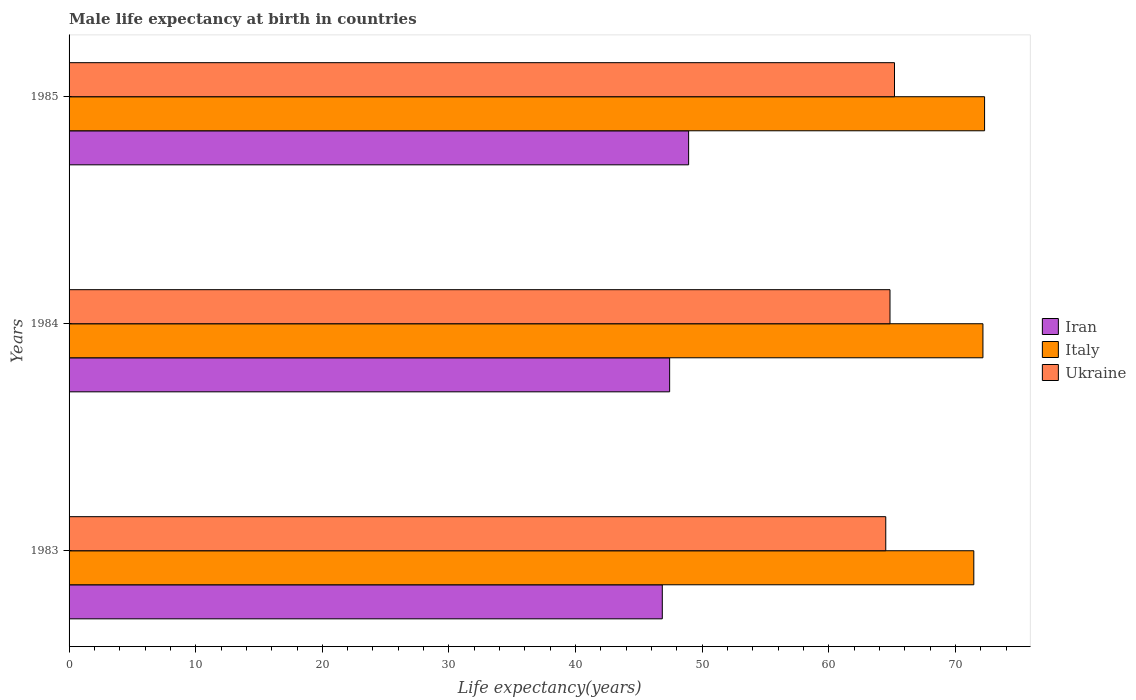Are the number of bars per tick equal to the number of legend labels?
Keep it short and to the point. Yes. Are the number of bars on each tick of the Y-axis equal?
Provide a short and direct response. Yes. How many bars are there on the 3rd tick from the top?
Your response must be concise. 3. How many bars are there on the 2nd tick from the bottom?
Make the answer very short. 3. What is the label of the 3rd group of bars from the top?
Keep it short and to the point. 1983. What is the male life expectancy at birth in Iran in 1983?
Keep it short and to the point. 46.85. Across all years, what is the maximum male life expectancy at birth in Ukraine?
Offer a terse response. 65.19. Across all years, what is the minimum male life expectancy at birth in Iran?
Ensure brevity in your answer.  46.85. In which year was the male life expectancy at birth in Iran minimum?
Make the answer very short. 1983. What is the total male life expectancy at birth in Iran in the graph?
Your answer should be very brief. 143.21. What is the difference between the male life expectancy at birth in Italy in 1983 and that in 1984?
Your response must be concise. -0.72. What is the difference between the male life expectancy at birth in Italy in 1985 and the male life expectancy at birth in Iran in 1984?
Offer a terse response. 24.87. What is the average male life expectancy at birth in Italy per year?
Your answer should be compact. 71.97. In the year 1985, what is the difference between the male life expectancy at birth in Italy and male life expectancy at birth in Iran?
Keep it short and to the point. 23.37. In how many years, is the male life expectancy at birth in Iran greater than 28 years?
Provide a short and direct response. 3. What is the ratio of the male life expectancy at birth in Ukraine in 1983 to that in 1984?
Offer a very short reply. 0.99. What is the difference between the highest and the second highest male life expectancy at birth in Ukraine?
Make the answer very short. 0.36. What is the difference between the highest and the lowest male life expectancy at birth in Iran?
Your answer should be compact. 2.08. What does the 1st bar from the top in 1984 represents?
Offer a terse response. Ukraine. What does the 1st bar from the bottom in 1984 represents?
Your response must be concise. Iran. Is it the case that in every year, the sum of the male life expectancy at birth in Italy and male life expectancy at birth in Iran is greater than the male life expectancy at birth in Ukraine?
Offer a terse response. Yes. How many years are there in the graph?
Your answer should be compact. 3. Are the values on the major ticks of X-axis written in scientific E-notation?
Provide a succinct answer. No. Does the graph contain grids?
Provide a short and direct response. No. Where does the legend appear in the graph?
Provide a succinct answer. Center right. What is the title of the graph?
Your response must be concise. Male life expectancy at birth in countries. Does "Kuwait" appear as one of the legend labels in the graph?
Offer a terse response. No. What is the label or title of the X-axis?
Offer a very short reply. Life expectancy(years). What is the label or title of the Y-axis?
Your answer should be very brief. Years. What is the Life expectancy(years) in Iran in 1983?
Your response must be concise. 46.85. What is the Life expectancy(years) in Italy in 1983?
Offer a very short reply. 71.45. What is the Life expectancy(years) of Ukraine in 1983?
Make the answer very short. 64.5. What is the Life expectancy(years) in Iran in 1984?
Offer a very short reply. 47.43. What is the Life expectancy(years) of Italy in 1984?
Provide a short and direct response. 72.17. What is the Life expectancy(years) in Ukraine in 1984?
Ensure brevity in your answer.  64.83. What is the Life expectancy(years) in Iran in 1985?
Your response must be concise. 48.93. What is the Life expectancy(years) in Italy in 1985?
Keep it short and to the point. 72.3. What is the Life expectancy(years) in Ukraine in 1985?
Ensure brevity in your answer.  65.19. Across all years, what is the maximum Life expectancy(years) in Iran?
Offer a very short reply. 48.93. Across all years, what is the maximum Life expectancy(years) of Italy?
Give a very brief answer. 72.3. Across all years, what is the maximum Life expectancy(years) of Ukraine?
Your answer should be very brief. 65.19. Across all years, what is the minimum Life expectancy(years) of Iran?
Your answer should be very brief. 46.85. Across all years, what is the minimum Life expectancy(years) of Italy?
Your answer should be very brief. 71.45. Across all years, what is the minimum Life expectancy(years) of Ukraine?
Give a very brief answer. 64.5. What is the total Life expectancy(years) in Iran in the graph?
Provide a short and direct response. 143.21. What is the total Life expectancy(years) of Italy in the graph?
Provide a succinct answer. 215.92. What is the total Life expectancy(years) in Ukraine in the graph?
Provide a succinct answer. 194.51. What is the difference between the Life expectancy(years) in Iran in 1983 and that in 1984?
Offer a very short reply. -0.58. What is the difference between the Life expectancy(years) in Italy in 1983 and that in 1984?
Your answer should be compact. -0.72. What is the difference between the Life expectancy(years) of Ukraine in 1983 and that in 1984?
Ensure brevity in your answer.  -0.33. What is the difference between the Life expectancy(years) in Iran in 1983 and that in 1985?
Offer a terse response. -2.08. What is the difference between the Life expectancy(years) in Italy in 1983 and that in 1985?
Give a very brief answer. -0.85. What is the difference between the Life expectancy(years) in Ukraine in 1983 and that in 1985?
Offer a terse response. -0.69. What is the difference between the Life expectancy(years) in Iran in 1984 and that in 1985?
Make the answer very short. -1.5. What is the difference between the Life expectancy(years) in Italy in 1984 and that in 1985?
Keep it short and to the point. -0.13. What is the difference between the Life expectancy(years) in Ukraine in 1984 and that in 1985?
Offer a terse response. -0.35. What is the difference between the Life expectancy(years) in Iran in 1983 and the Life expectancy(years) in Italy in 1984?
Your answer should be very brief. -25.32. What is the difference between the Life expectancy(years) of Iran in 1983 and the Life expectancy(years) of Ukraine in 1984?
Keep it short and to the point. -17.98. What is the difference between the Life expectancy(years) in Italy in 1983 and the Life expectancy(years) in Ukraine in 1984?
Give a very brief answer. 6.62. What is the difference between the Life expectancy(years) in Iran in 1983 and the Life expectancy(years) in Italy in 1985?
Provide a short and direct response. -25.45. What is the difference between the Life expectancy(years) in Iran in 1983 and the Life expectancy(years) in Ukraine in 1985?
Your answer should be very brief. -18.34. What is the difference between the Life expectancy(years) in Italy in 1983 and the Life expectancy(years) in Ukraine in 1985?
Give a very brief answer. 6.26. What is the difference between the Life expectancy(years) of Iran in 1984 and the Life expectancy(years) of Italy in 1985?
Your answer should be compact. -24.87. What is the difference between the Life expectancy(years) of Iran in 1984 and the Life expectancy(years) of Ukraine in 1985?
Provide a succinct answer. -17.76. What is the difference between the Life expectancy(years) in Italy in 1984 and the Life expectancy(years) in Ukraine in 1985?
Ensure brevity in your answer.  6.98. What is the average Life expectancy(years) of Iran per year?
Offer a terse response. 47.74. What is the average Life expectancy(years) of Italy per year?
Your response must be concise. 71.97. What is the average Life expectancy(years) of Ukraine per year?
Ensure brevity in your answer.  64.84. In the year 1983, what is the difference between the Life expectancy(years) of Iran and Life expectancy(years) of Italy?
Provide a succinct answer. -24.6. In the year 1983, what is the difference between the Life expectancy(years) in Iran and Life expectancy(years) in Ukraine?
Make the answer very short. -17.65. In the year 1983, what is the difference between the Life expectancy(years) of Italy and Life expectancy(years) of Ukraine?
Give a very brief answer. 6.95. In the year 1984, what is the difference between the Life expectancy(years) of Iran and Life expectancy(years) of Italy?
Make the answer very short. -24.74. In the year 1984, what is the difference between the Life expectancy(years) of Iran and Life expectancy(years) of Ukraine?
Offer a terse response. -17.4. In the year 1984, what is the difference between the Life expectancy(years) in Italy and Life expectancy(years) in Ukraine?
Offer a very short reply. 7.34. In the year 1985, what is the difference between the Life expectancy(years) in Iran and Life expectancy(years) in Italy?
Provide a succinct answer. -23.37. In the year 1985, what is the difference between the Life expectancy(years) in Iran and Life expectancy(years) in Ukraine?
Your answer should be compact. -16.26. In the year 1985, what is the difference between the Life expectancy(years) in Italy and Life expectancy(years) in Ukraine?
Provide a succinct answer. 7.11. What is the ratio of the Life expectancy(years) of Iran in 1983 to that in 1984?
Ensure brevity in your answer.  0.99. What is the ratio of the Life expectancy(years) in Iran in 1983 to that in 1985?
Ensure brevity in your answer.  0.96. What is the ratio of the Life expectancy(years) of Iran in 1984 to that in 1985?
Give a very brief answer. 0.97. What is the difference between the highest and the second highest Life expectancy(years) of Iran?
Your answer should be very brief. 1.5. What is the difference between the highest and the second highest Life expectancy(years) of Italy?
Offer a terse response. 0.13. What is the difference between the highest and the second highest Life expectancy(years) of Ukraine?
Your response must be concise. 0.35. What is the difference between the highest and the lowest Life expectancy(years) in Iran?
Your response must be concise. 2.08. What is the difference between the highest and the lowest Life expectancy(years) of Ukraine?
Your response must be concise. 0.69. 